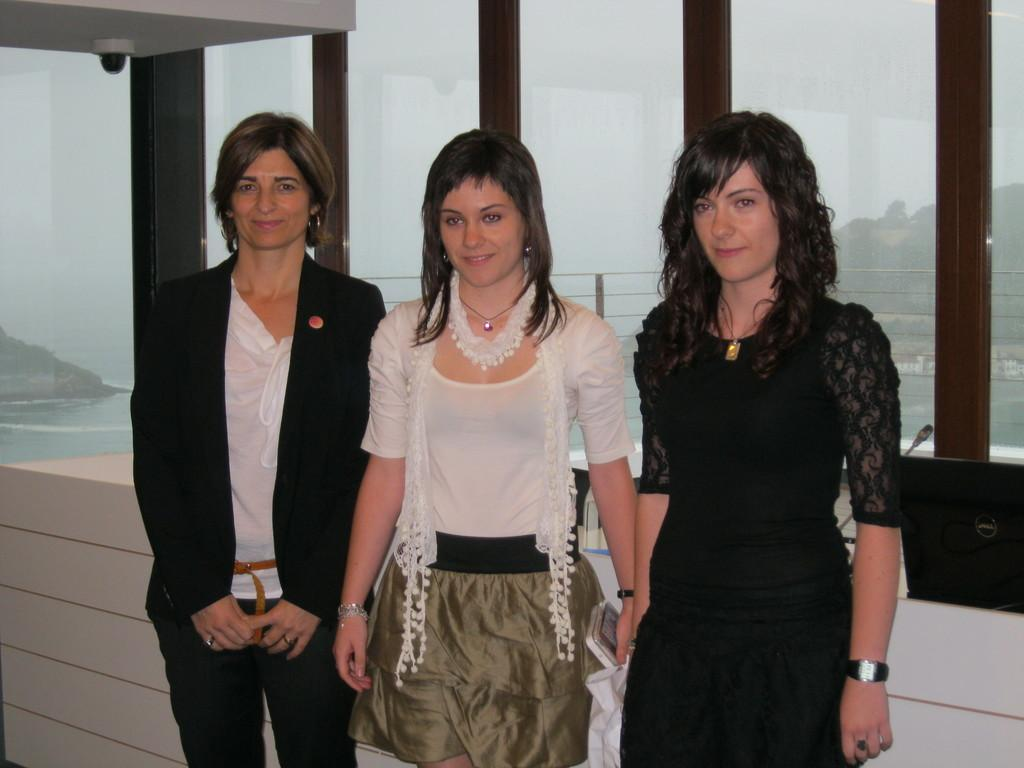How many women are in the image? There are three women in the image. What is in the background of the image? There is a glass wall in the background of the image. What can be seen through the glass wall? Mountains, the sea, and the sky are visible through the glass wall. What type of bat is flying in the image? There is no bat present in the image. What is the temper of the family in the image? There is no family present in the image, and therefore no temper can be determined. 